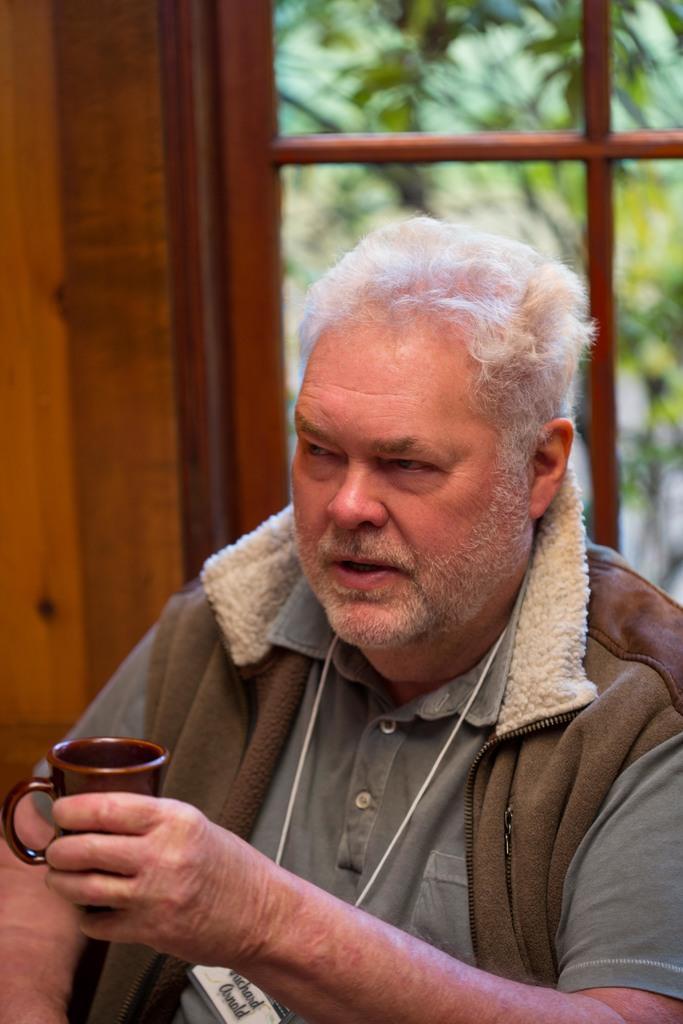How would you summarize this image in a sentence or two? A man with brown jacket and green t-shirt is holding a cup in his hand. Behind him there is window. Outside the window there is a tree. To the left side there is a wooden wall. 